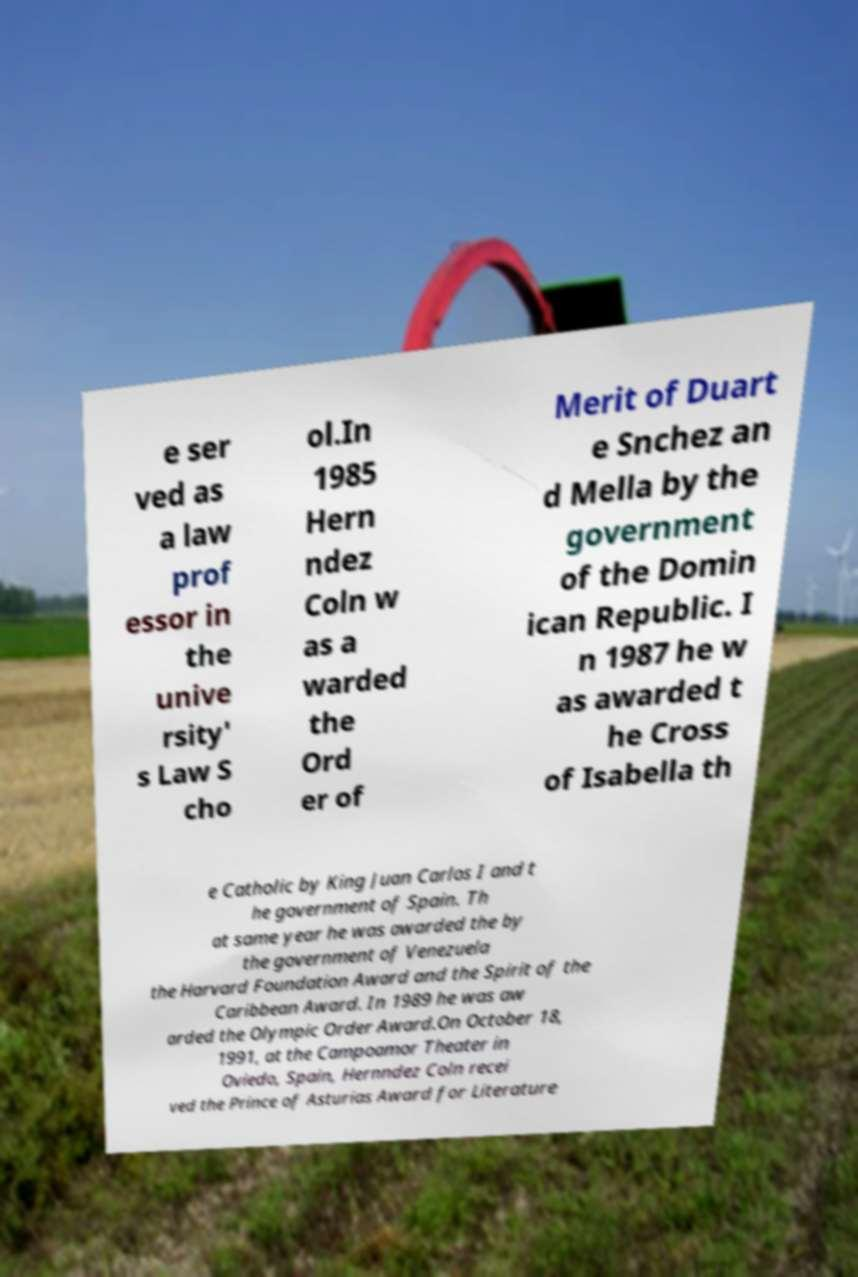Could you extract and type out the text from this image? e ser ved as a law prof essor in the unive rsity' s Law S cho ol.In 1985 Hern ndez Coln w as a warded the Ord er of Merit of Duart e Snchez an d Mella by the government of the Domin ican Republic. I n 1987 he w as awarded t he Cross of Isabella th e Catholic by King Juan Carlos I and t he government of Spain. Th at same year he was awarded the by the government of Venezuela the Harvard Foundation Award and the Spirit of the Caribbean Award. In 1989 he was aw arded the Olympic Order Award.On October 18, 1991, at the Campoamor Theater in Oviedo, Spain, Hernndez Coln recei ved the Prince of Asturias Award for Literature 